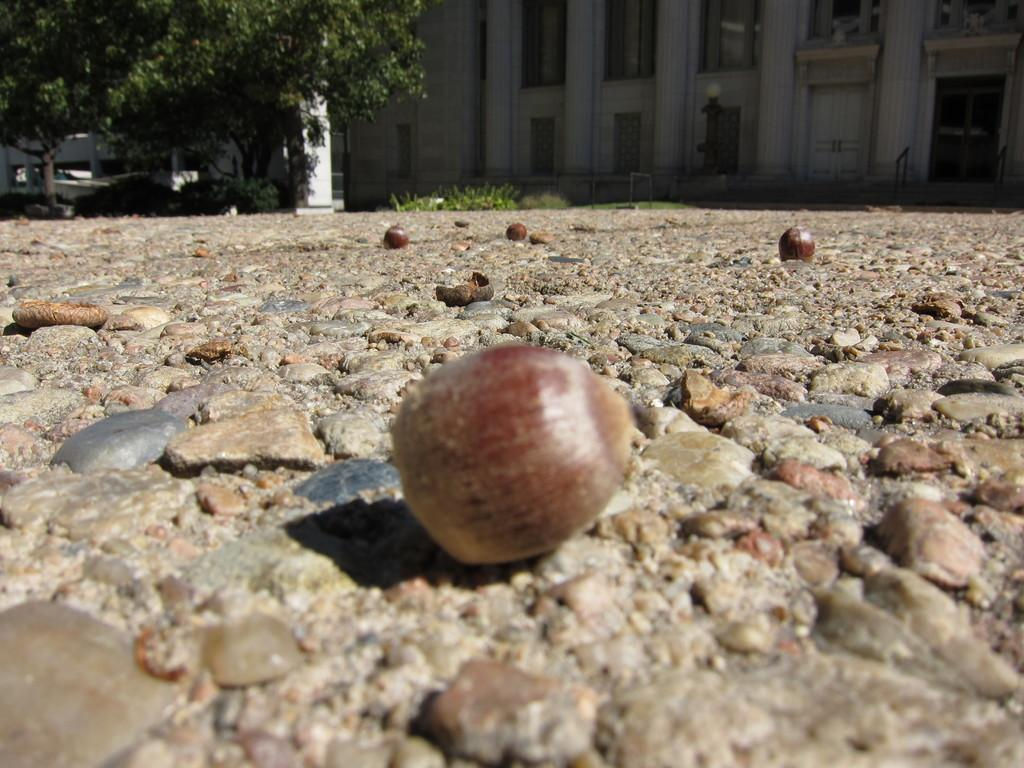What is on the floor in the image? There are fruits on the floor in the image. What else can be seen in the image besides the fruits? There are rocks, a tree on the left side, and a building in the image. Can you describe the building in the image? The building has windows and doors. What type of lip can be seen on the tree in the image? There is no lip present on the tree in the image. 